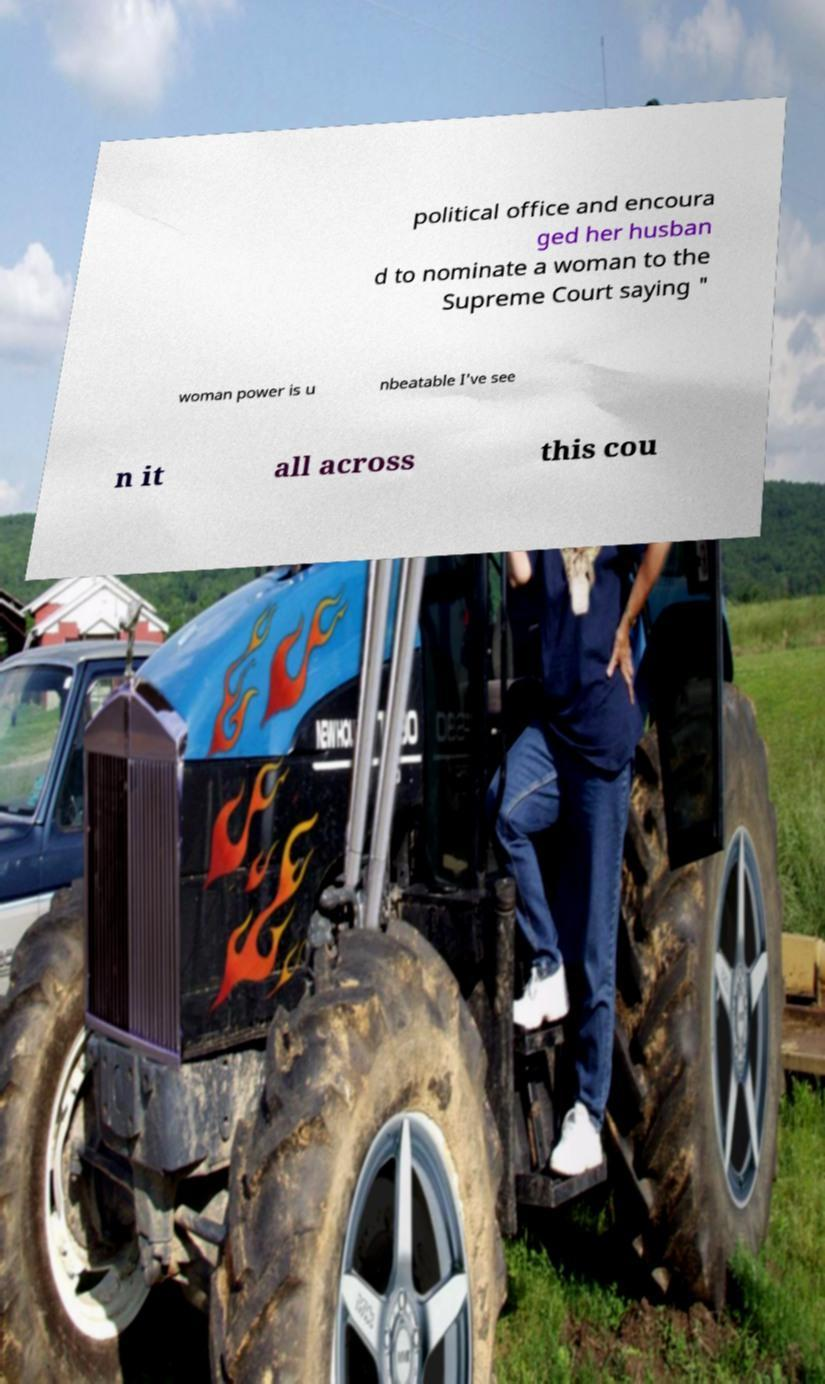For documentation purposes, I need the text within this image transcribed. Could you provide that? political office and encoura ged her husban d to nominate a woman to the Supreme Court saying " woman power is u nbeatable I've see n it all across this cou 